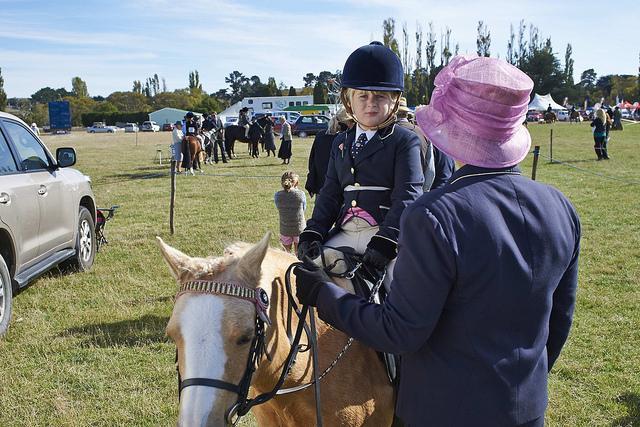How many people can you see?
Give a very brief answer. 2. How many dogs are running in the surf?
Give a very brief answer. 0. 